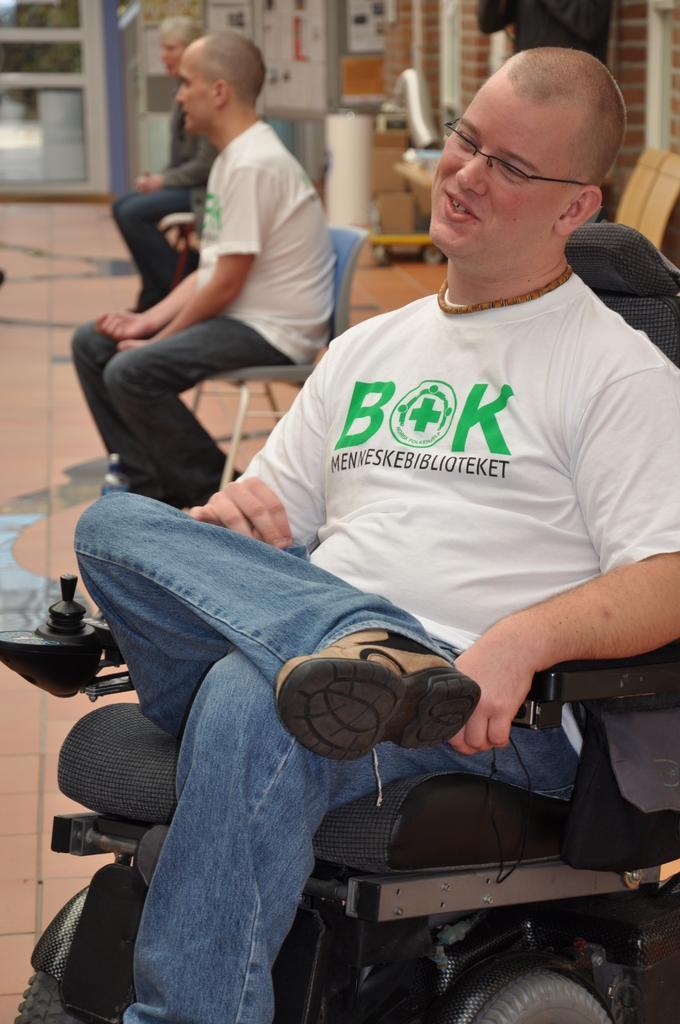Can you describe this image briefly? In this image there are a few people sitting on the chairs. Behind them there are a few objects. In the background of the image there is a wall. There is a glass door through which we can see trees. 